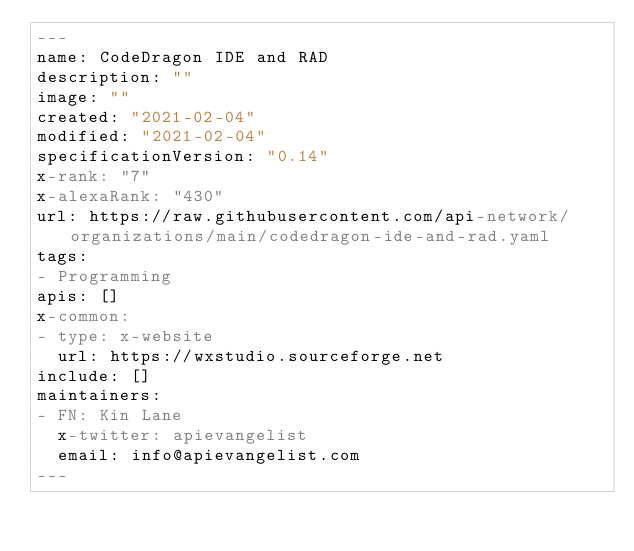Convert code to text. <code><loc_0><loc_0><loc_500><loc_500><_YAML_>---
name: CodeDragon IDE and RAD
description: ""
image: ""
created: "2021-02-04"
modified: "2021-02-04"
specificationVersion: "0.14"
x-rank: "7"
x-alexaRank: "430"
url: https://raw.githubusercontent.com/api-network/organizations/main/codedragon-ide-and-rad.yaml
tags:
- Programming
apis: []
x-common:
- type: x-website
  url: https://wxstudio.sourceforge.net
include: []
maintainers:
- FN: Kin Lane
  x-twitter: apievangelist
  email: info@apievangelist.com
---</code> 